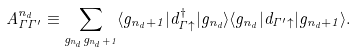Convert formula to latex. <formula><loc_0><loc_0><loc_500><loc_500>A _ { \Gamma \Gamma ^ { \prime } } ^ { n _ { d } } \equiv \sum _ { g _ { n _ { d } } g _ { n _ { d } + 1 } } \langle g _ { n _ { d } + 1 } | d ^ { \dagger } _ { \Gamma \uparrow } | g _ { n _ { d } } \rangle \langle g _ { n _ { d } } | d _ { \Gamma ^ { \prime } \uparrow } | g _ { n _ { d } + 1 } \rangle .</formula> 